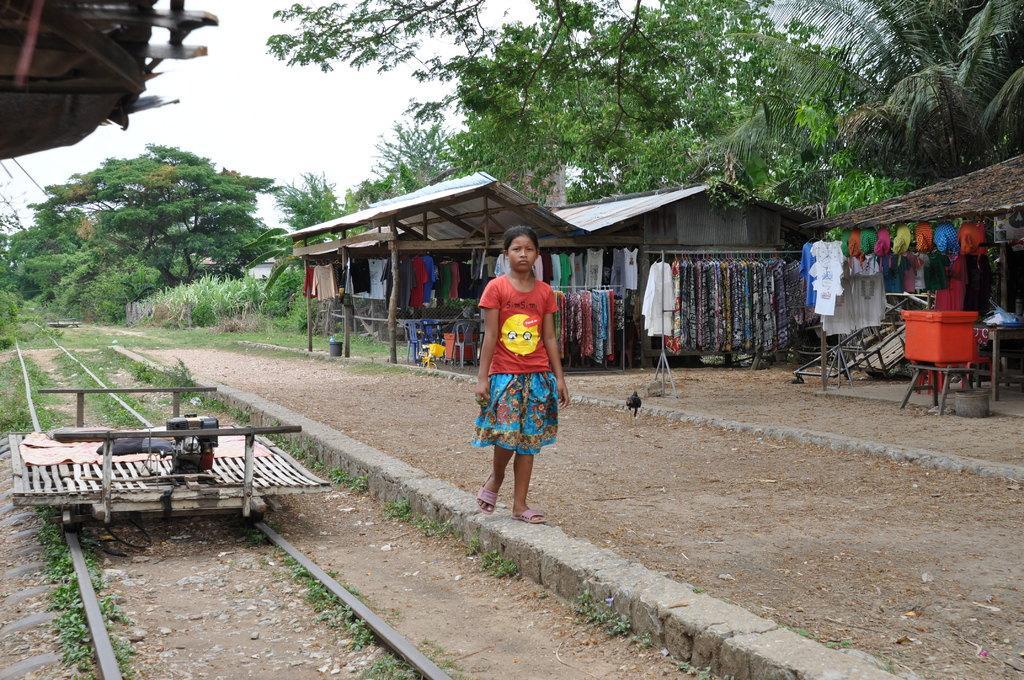Can you describe this image briefly? This picture shows couple of houses and we see clothes hanging to the hangers and we see a plastic box on the table and we see a railway track on the side and we see a girl standing and we see trees and a cloudy Sky. 